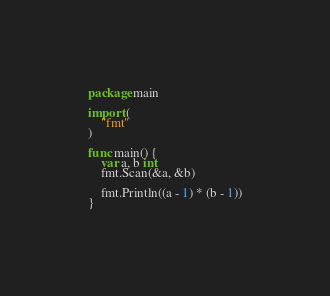<code> <loc_0><loc_0><loc_500><loc_500><_Go_>package main

import (
	"fmt"
)

func main() {
	var a, b int
	fmt.Scan(&a, &b)

	fmt.Println((a - 1) * (b - 1))
}
</code> 